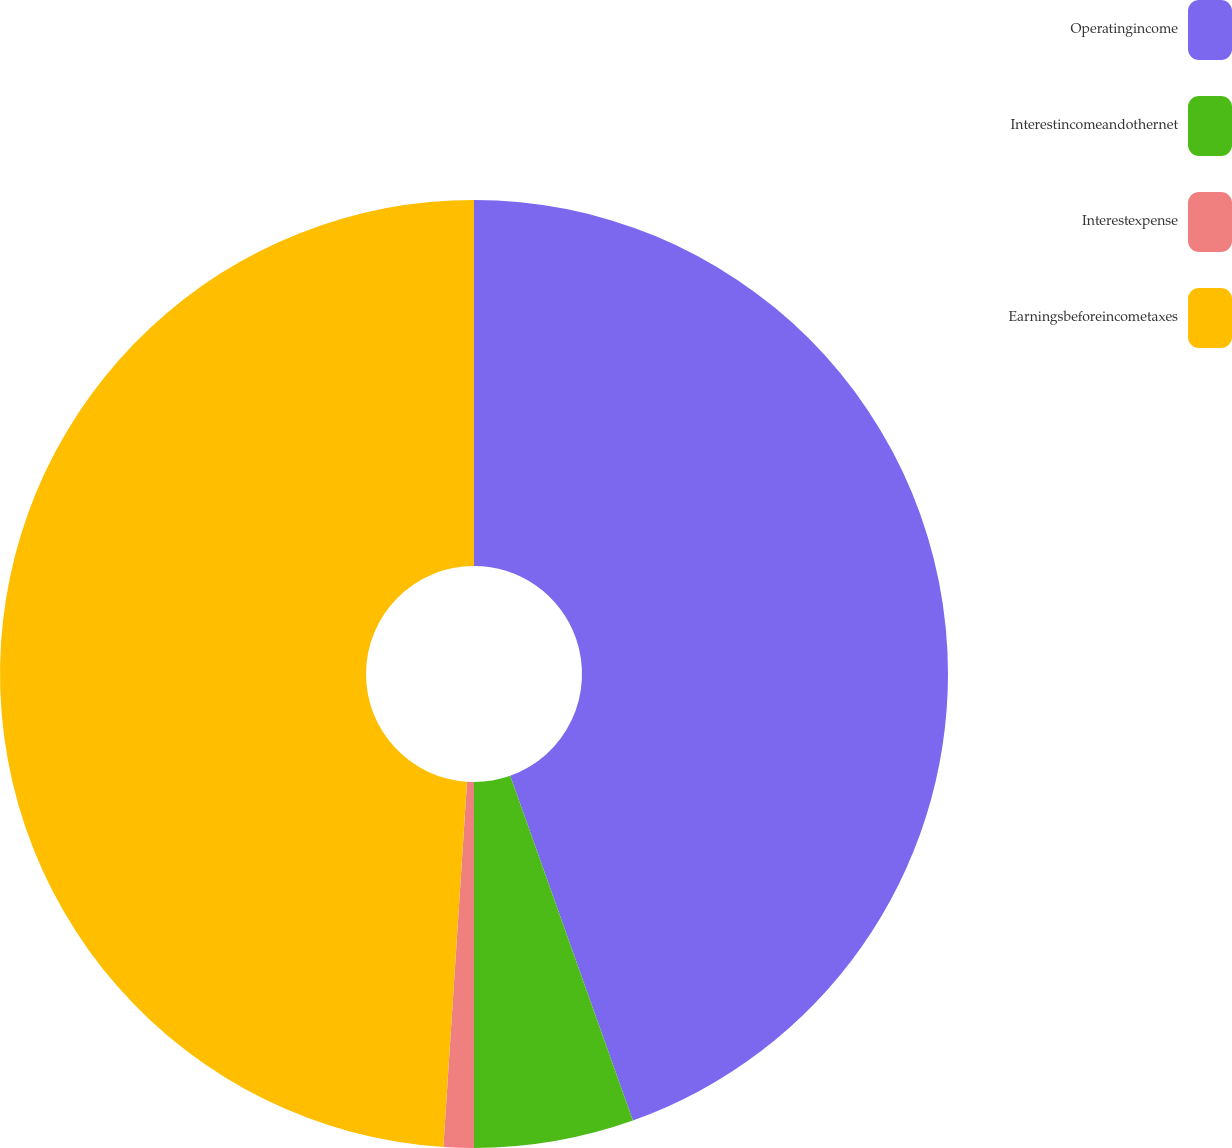<chart> <loc_0><loc_0><loc_500><loc_500><pie_chart><fcel>Operatingincome<fcel>Interestincomeandothernet<fcel>Interestexpense<fcel>Earningsbeforeincometaxes<nl><fcel>44.56%<fcel>5.44%<fcel>1.03%<fcel>48.97%<nl></chart> 